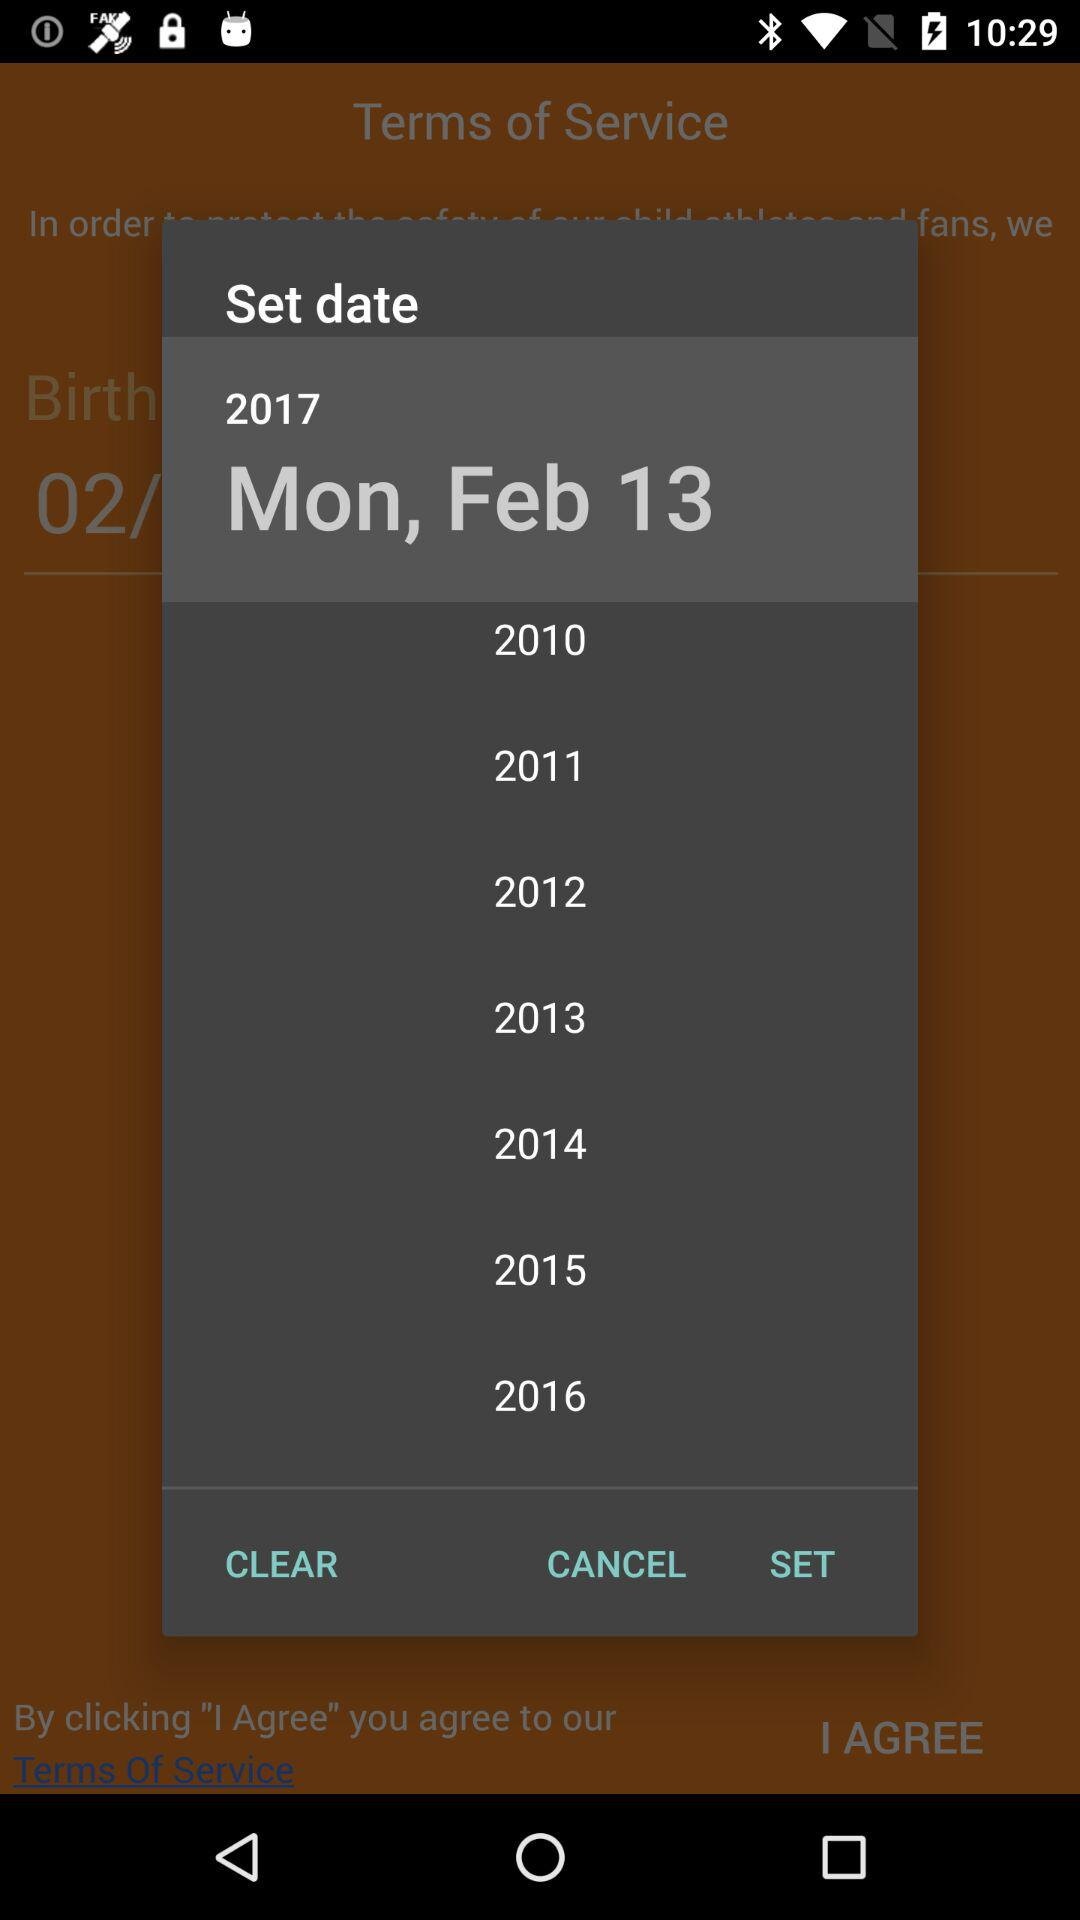Which date is set on the screen? The set date is Monday, February 13, 2017. 